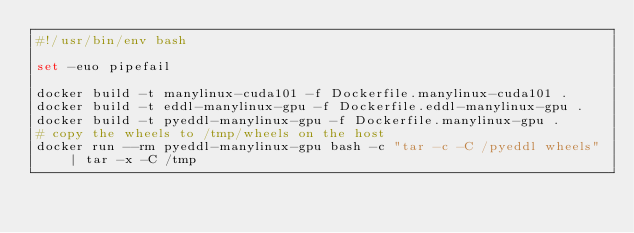<code> <loc_0><loc_0><loc_500><loc_500><_Bash_>#!/usr/bin/env bash

set -euo pipefail

docker build -t manylinux-cuda101 -f Dockerfile.manylinux-cuda101 .
docker build -t eddl-manylinux-gpu -f Dockerfile.eddl-manylinux-gpu .
docker build -t pyeddl-manylinux-gpu -f Dockerfile.manylinux-gpu .
# copy the wheels to /tmp/wheels on the host
docker run --rm pyeddl-manylinux-gpu bash -c "tar -c -C /pyeddl wheels" | tar -x -C /tmp
</code> 